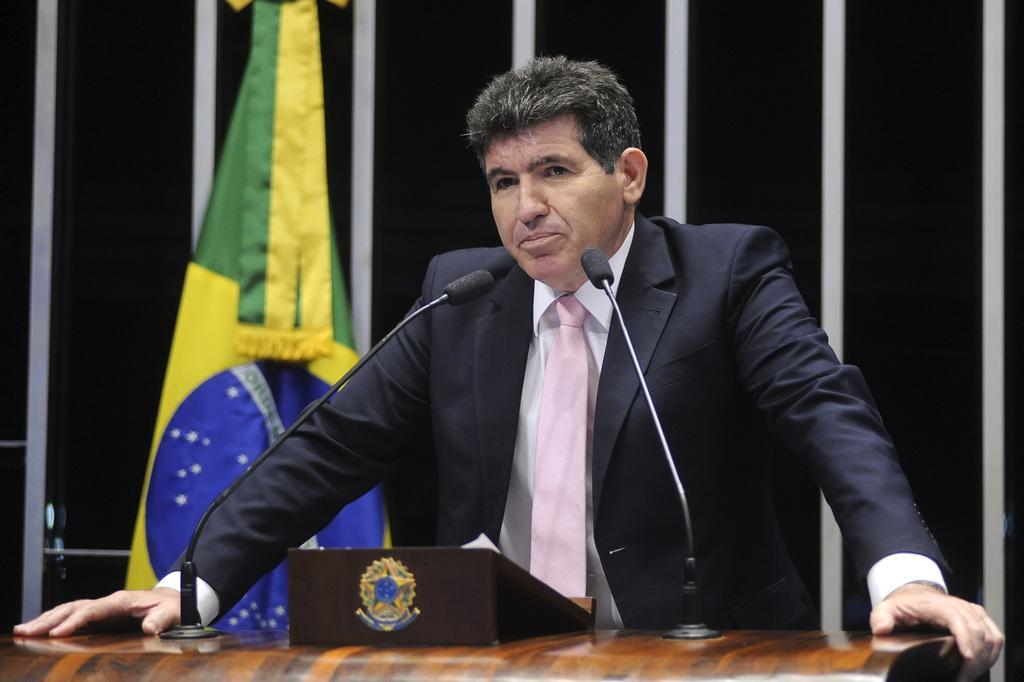Please provide a concise description of this image. In this image there is a person standing on the podium, on the podium there are two mics and an object, behind the person there is a flag on the wall. 